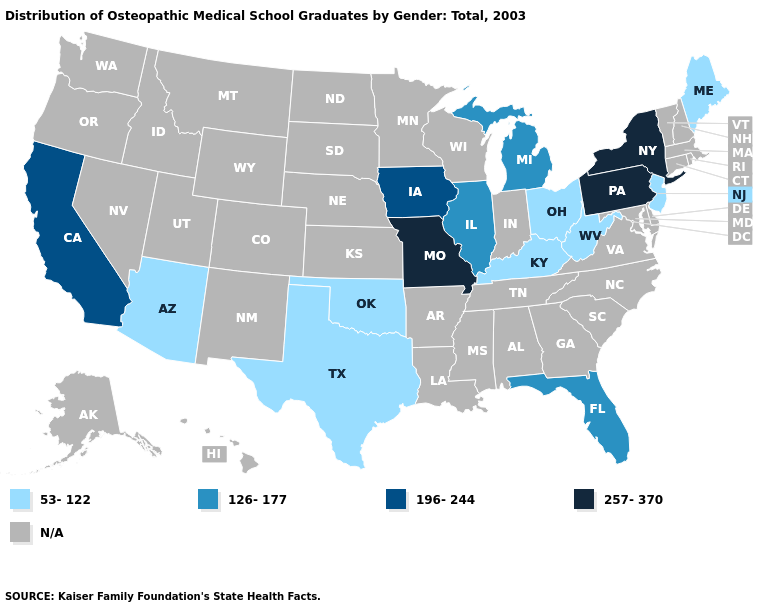What is the value of New Hampshire?
Give a very brief answer. N/A. Which states have the highest value in the USA?
Concise answer only. Missouri, New York, Pennsylvania. What is the value of South Dakota?
Quick response, please. N/A. Does the map have missing data?
Short answer required. Yes. Name the states that have a value in the range 126-177?
Be succinct. Florida, Illinois, Michigan. Name the states that have a value in the range 257-370?
Short answer required. Missouri, New York, Pennsylvania. Is the legend a continuous bar?
Concise answer only. No. Is the legend a continuous bar?
Be succinct. No. What is the value of South Dakota?
Give a very brief answer. N/A. Among the states that border Indiana , which have the highest value?
Concise answer only. Illinois, Michigan. What is the highest value in states that border Alabama?
Concise answer only. 126-177. Name the states that have a value in the range 257-370?
Answer briefly. Missouri, New York, Pennsylvania. Name the states that have a value in the range 257-370?
Concise answer only. Missouri, New York, Pennsylvania. What is the highest value in states that border Illinois?
Quick response, please. 257-370. Is the legend a continuous bar?
Keep it brief. No. 